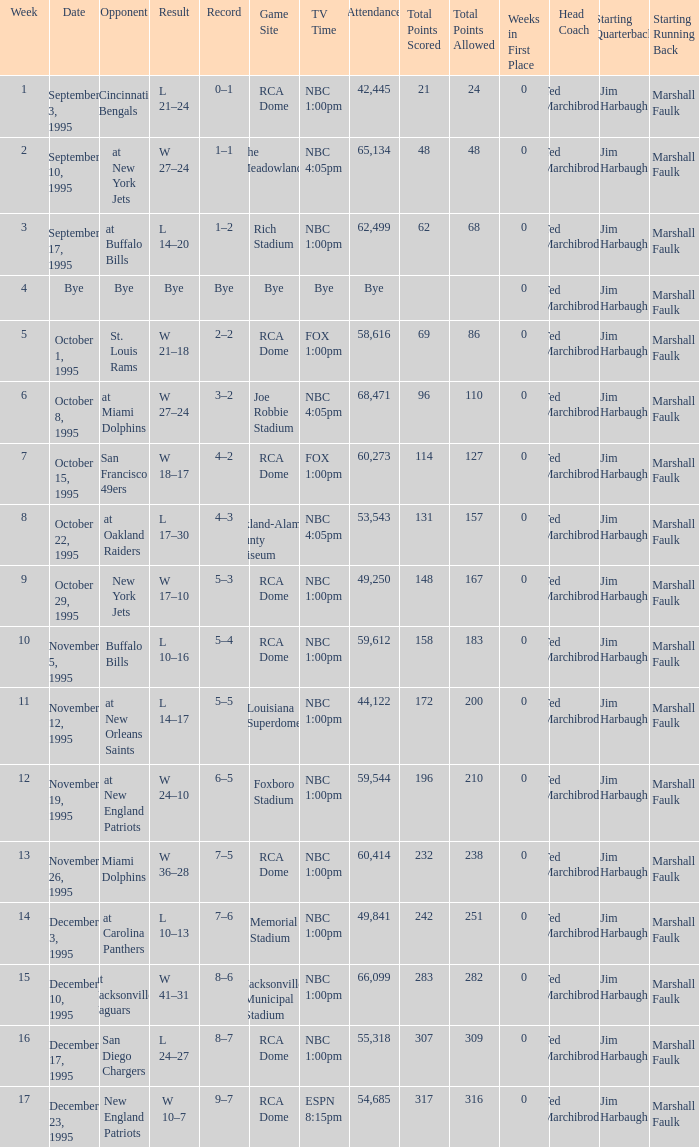What's the Opponent with a Week that's larger than 16? New England Patriots. 